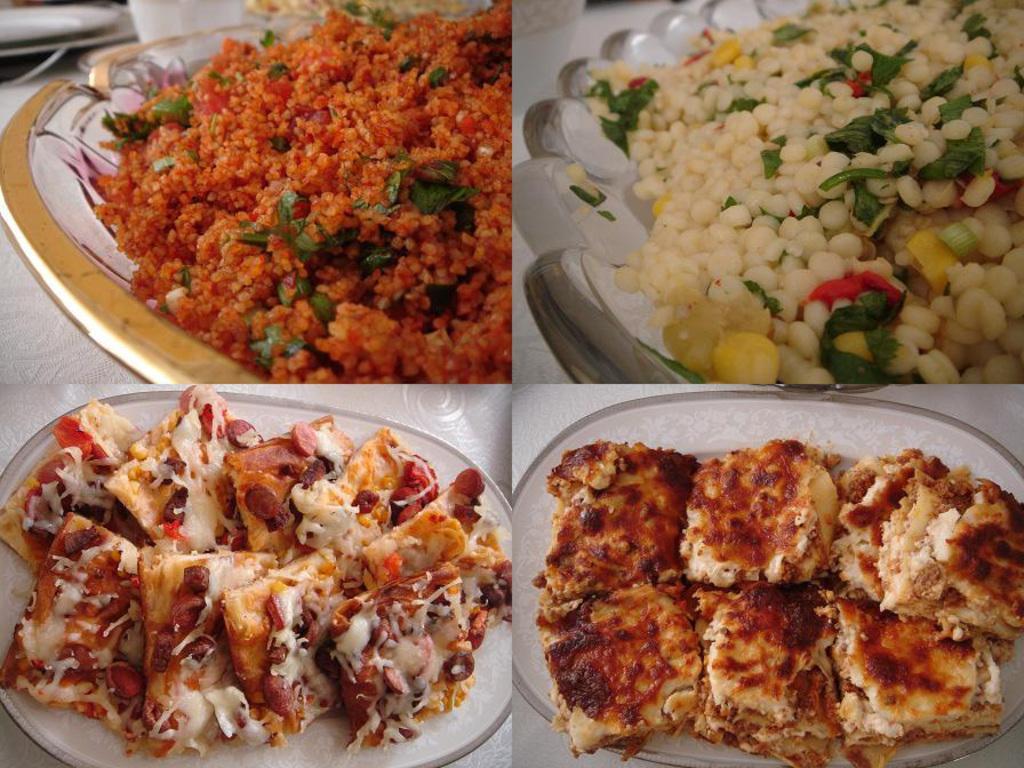How would you summarize this image in a sentence or two? It is a collage picture. In this image, we can see food items are in the plates. These plates are placed on the white surface. 